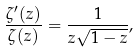<formula> <loc_0><loc_0><loc_500><loc_500>\frac { \zeta ^ { \prime } ( z ) } { \zeta ( z ) } = \frac { 1 } { z \sqrt { 1 - z } } , \</formula> 